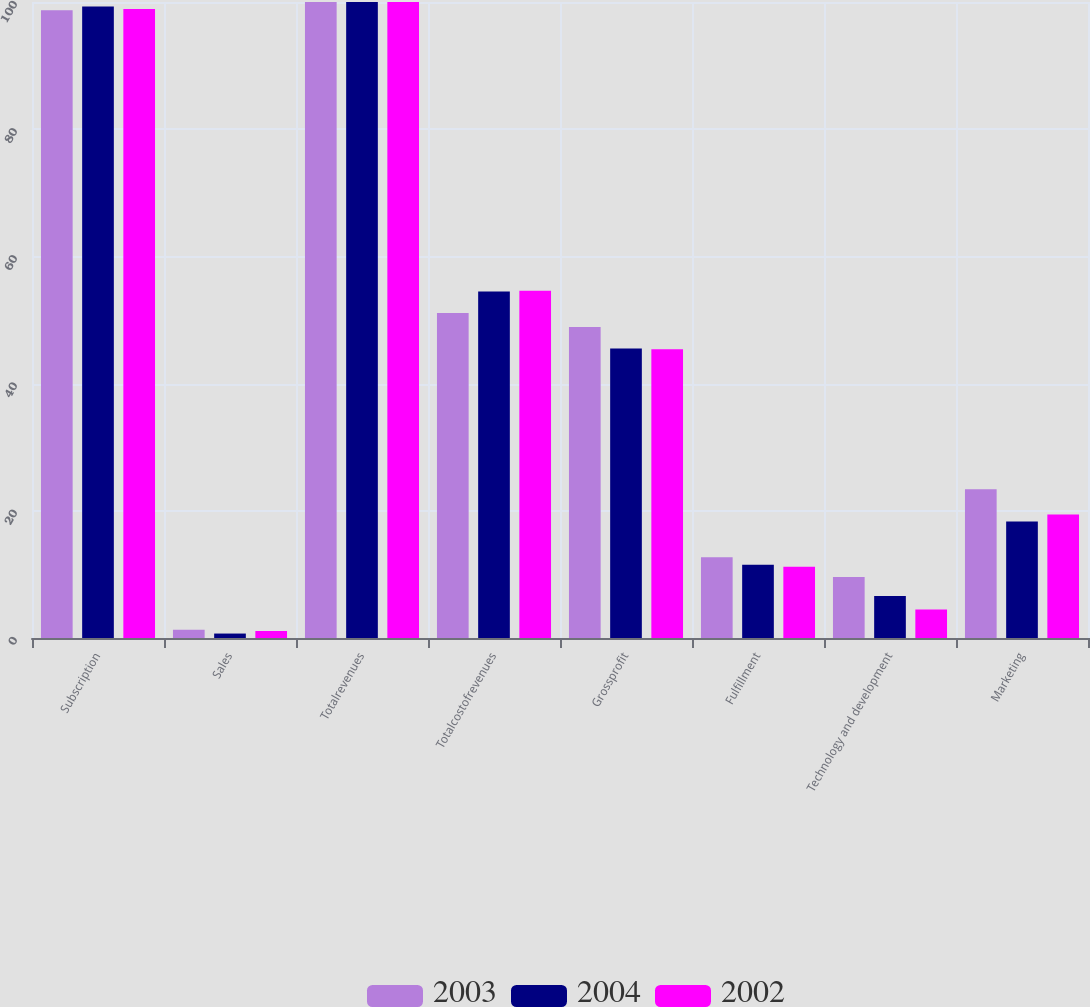Convert chart to OTSL. <chart><loc_0><loc_0><loc_500><loc_500><stacked_bar_chart><ecel><fcel>Subscription<fcel>Sales<fcel>Totalrevenues<fcel>Totalcostofrevenues<fcel>Grossprofit<fcel>Fulfillment<fcel>Technology and development<fcel>Marketing<nl><fcel>2003<fcel>98.7<fcel>1.3<fcel>100<fcel>51.1<fcel>48.9<fcel>12.7<fcel>9.6<fcel>23.4<nl><fcel>2004<fcel>99.3<fcel>0.7<fcel>100<fcel>54.5<fcel>45.5<fcel>11.5<fcel>6.6<fcel>18.3<nl><fcel>2002<fcel>98.9<fcel>1.1<fcel>100<fcel>54.6<fcel>45.4<fcel>11.2<fcel>4.5<fcel>19.4<nl></chart> 